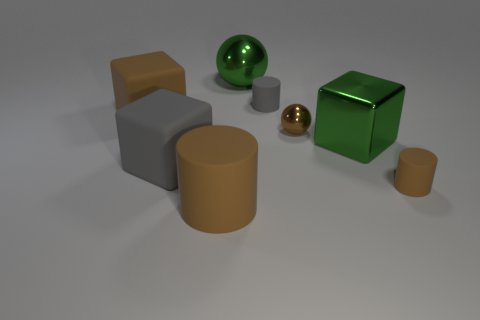How many cylinders are the same material as the small gray object?
Provide a succinct answer. 2. What color is the other small object that is made of the same material as the small gray object?
Your answer should be very brief. Brown. There is a green shiny object that is behind the big object that is to the left of the gray rubber object that is in front of the gray matte cylinder; what size is it?
Keep it short and to the point. Large. Is the number of small brown objects less than the number of tiny brown cubes?
Make the answer very short. No. What color is the other small object that is the same shape as the tiny gray object?
Ensure brevity in your answer.  Brown. There is a big green metal object that is in front of the green thing to the left of the small gray matte thing; are there any brown shiny spheres that are in front of it?
Provide a short and direct response. No. Is the shape of the large gray rubber object the same as the tiny shiny thing?
Give a very brief answer. No. Is the number of metal spheres on the left side of the small gray rubber thing less than the number of green matte blocks?
Your answer should be very brief. No. What is the color of the large metallic thing to the right of the gray cylinder behind the small matte cylinder that is in front of the green metal block?
Give a very brief answer. Green. How many matte things are tiny gray cylinders or big brown objects?
Your answer should be compact. 3. 